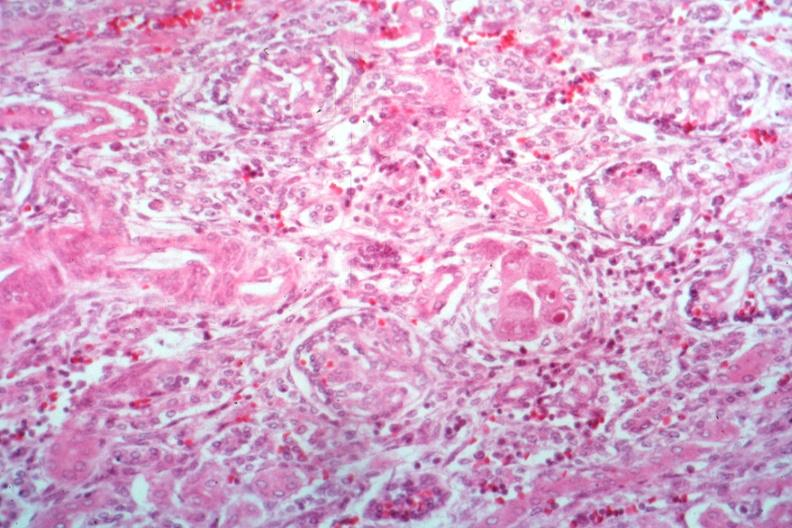what is present?
Answer the question using a single word or phrase. Kidney 